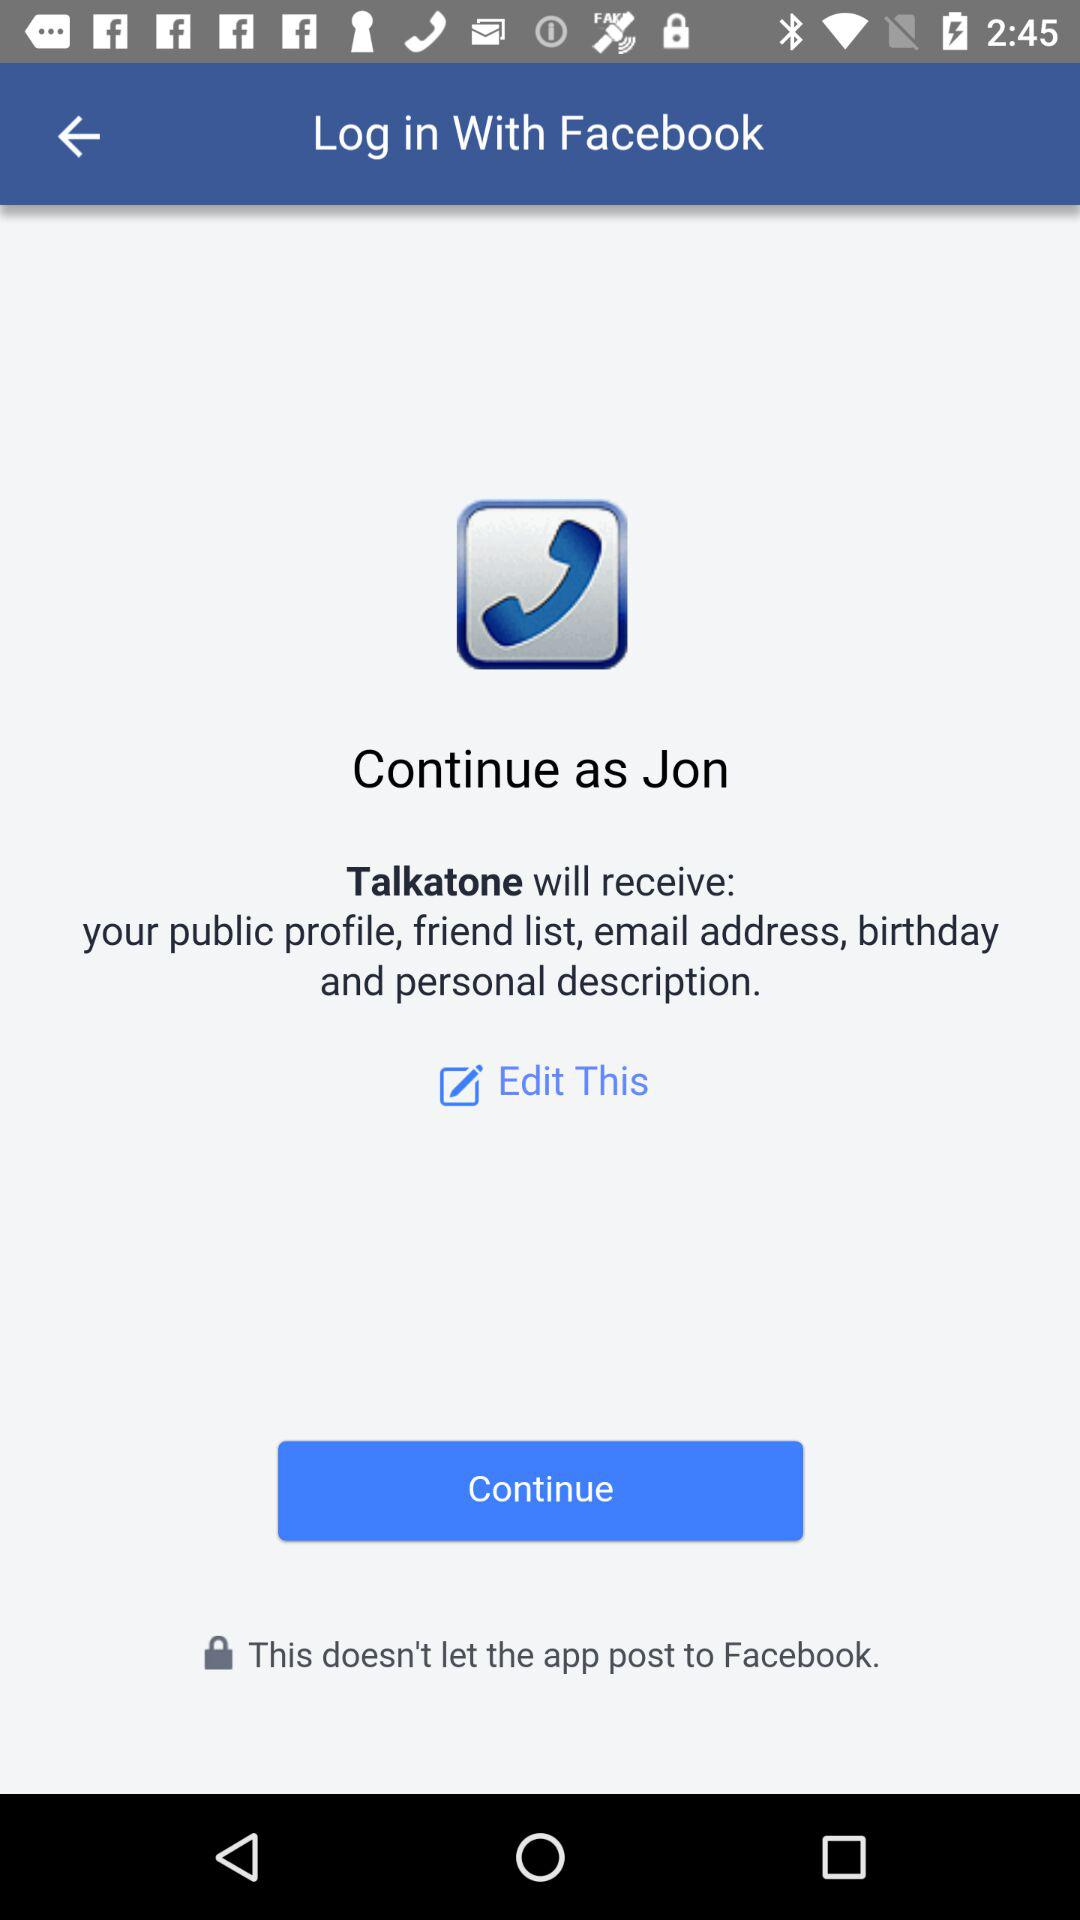What is the user's name? The user's name is "Jon". 